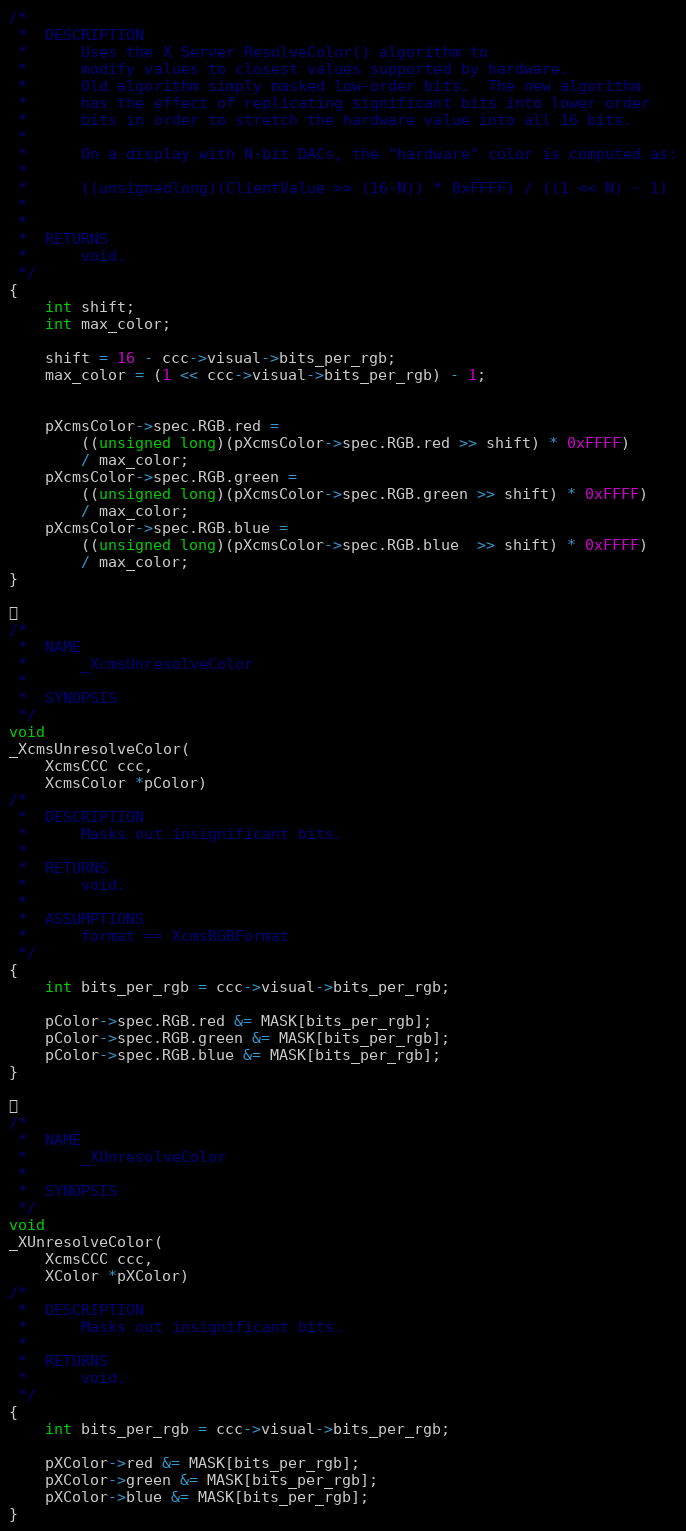Convert code to text. <code><loc_0><loc_0><loc_500><loc_500><_C_>/*
 *	DESCRIPTION
 *	    Uses the X Server ResolveColor() algorithm to
 *	    modify values to closest values supported by hardware.
 *	    Old algorithm simply masked low-order bits.  The new algorithm
 *	    has the effect of replicating significant bits into lower order
 *	    bits in order to stretch the hardware value into all 16 bits.
 *
 *	    On a display with N-bit DACs, the "hardware" color is computed as:
 *
 *	    ((unsignedlong)(ClientValue >> (16-N)) * 0xFFFF) / ((1 << N) - 1)
 *
 *
 *	RETURNS
 *		void.
 */
{
    int shift;
    int max_color;

    shift = 16 - ccc->visual->bits_per_rgb;
    max_color = (1 << ccc->visual->bits_per_rgb) - 1;


    pXcmsColor->spec.RGB.red =
	    ((unsigned long)(pXcmsColor->spec.RGB.red >> shift) * 0xFFFF)
	    / max_color;
    pXcmsColor->spec.RGB.green =
	    ((unsigned long)(pXcmsColor->spec.RGB.green >> shift) * 0xFFFF)
	    / max_color;
    pXcmsColor->spec.RGB.blue =
	    ((unsigned long)(pXcmsColor->spec.RGB.blue  >> shift) * 0xFFFF)
	    / max_color;
}


/*
 *	NAME
 *		_XcmsUnresolveColor
 *
 *	SYNOPSIS
 */
void
_XcmsUnresolveColor(
    XcmsCCC ccc,
    XcmsColor *pColor)
/*
 *	DESCRIPTION
 *		Masks out insignificant bits.
 *
 *	RETURNS
 *		void.
 *
 *	ASSUMPTIONS
 *		format == XcmsRGBFormat
 */
{
    int bits_per_rgb = ccc->visual->bits_per_rgb;

    pColor->spec.RGB.red &= MASK[bits_per_rgb];
    pColor->spec.RGB.green &= MASK[bits_per_rgb];
    pColor->spec.RGB.blue &= MASK[bits_per_rgb];
}


/*
 *	NAME
 *		_XUnresolveColor
 *
 *	SYNOPSIS
 */
void
_XUnresolveColor(
    XcmsCCC ccc,
    XColor *pXColor)
/*
 *	DESCRIPTION
 *		Masks out insignificant bits.
 *
 *	RETURNS
 *		void.
 */
{
    int bits_per_rgb = ccc->visual->bits_per_rgb;

    pXColor->red &= MASK[bits_per_rgb];
    pXColor->green &= MASK[bits_per_rgb];
    pXColor->blue &= MASK[bits_per_rgb];
}

</code> 